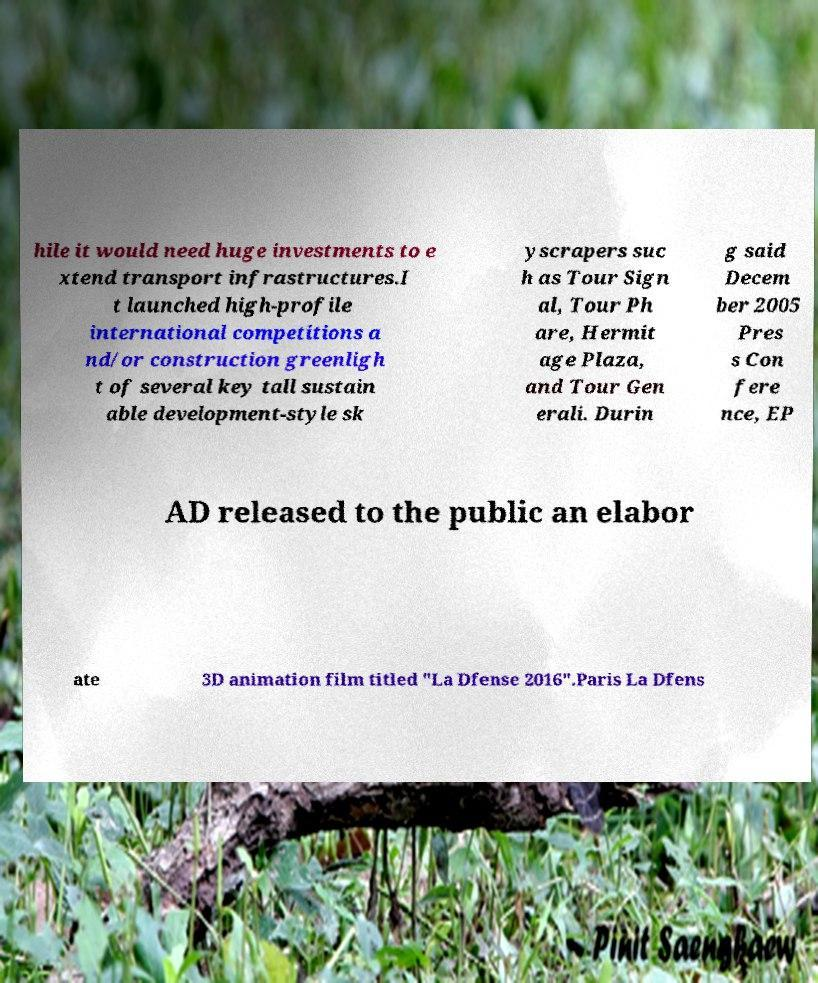I need the written content from this picture converted into text. Can you do that? hile it would need huge investments to e xtend transport infrastructures.I t launched high-profile international competitions a nd/or construction greenligh t of several key tall sustain able development-style sk yscrapers suc h as Tour Sign al, Tour Ph are, Hermit age Plaza, and Tour Gen erali. Durin g said Decem ber 2005 Pres s Con fere nce, EP AD released to the public an elabor ate 3D animation film titled "La Dfense 2016".Paris La Dfens 